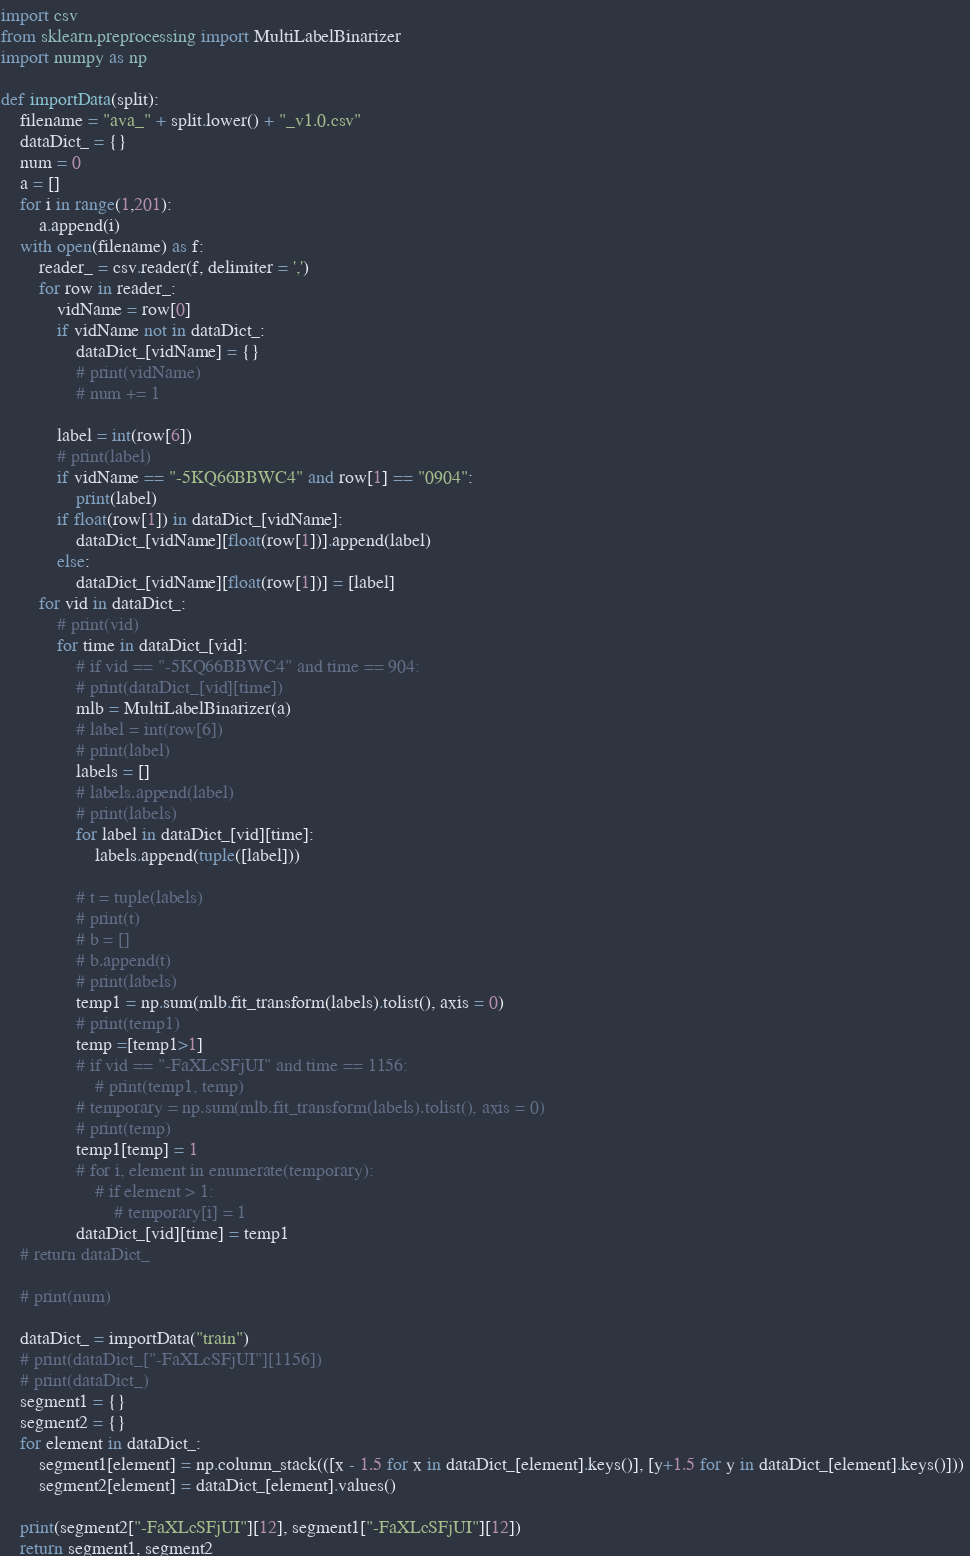<code> <loc_0><loc_0><loc_500><loc_500><_Python_>import csv
from sklearn.preprocessing import MultiLabelBinarizer
import numpy as np

def importData(split):
	filename = "ava_" + split.lower() + "_v1.0.csv"
	dataDict_ = {}
	num = 0
	a = []
	for i in range(1,201):
		a.append(i)
	with open(filename) as f:
		reader_ = csv.reader(f, delimiter = ',')
		for row in reader_:
			vidName = row[0]
			if vidName not in dataDict_:
				dataDict_[vidName] = {}
				# print(vidName)
				# num += 1
			
			label = int(row[6])
			# print(label)
			if vidName == "-5KQ66BBWC4" and row[1] == "0904":
				print(label)
			if float(row[1]) in dataDict_[vidName]:
				dataDict_[vidName][float(row[1])].append(label)
			else:
				dataDict_[vidName][float(row[1])] = [label]
		for vid in dataDict_:
			# print(vid)
			for time in dataDict_[vid]:
				# if vid == "-5KQ66BBWC4" and time == 904:
				# print(dataDict_[vid][time])
				mlb = MultiLabelBinarizer(a)
				# label = int(row[6])
				# print(label)
				labels = []
				# labels.append(label)
				# print(labels)
				for label in dataDict_[vid][time]:
					labels.append(tuple([label]))

				# t = tuple(labels)
				# print(t)
				# b = []
				# b.append(t)
				# print(labels)
				temp1 = np.sum(mlb.fit_transform(labels).tolist(), axis = 0)
				# print(temp1)
				temp =[temp1>1]
				# if vid == "-FaXLcSFjUI" and time == 1156:
					# print(temp1, temp)
				# temporary = np.sum(mlb.fit_transform(labels).tolist(), axis = 0)
				# print(temp)
				temp1[temp] = 1
				# for i, element in enumerate(temporary):
					# if element > 1:
						# temporary[i] = 1
				dataDict_[vid][time] = temp1
	# return dataDict_
			
	# print(num)

	dataDict_ = importData("train")
	# print(dataDict_["-FaXLcSFjUI"][1156])
	# print(dataDict_)
	segment1 = {}
	segment2 = {}
	for element in dataDict_:
		segment1[element] = np.column_stack(([x - 1.5 for x in dataDict_[element].keys()], [y+1.5 for y in dataDict_[element].keys()])) 
		segment2[element] = dataDict_[element].values()

	print(segment2["-FaXLcSFjUI"][12], segment1["-FaXLcSFjUI"][12])
	return segment1, segment2</code> 